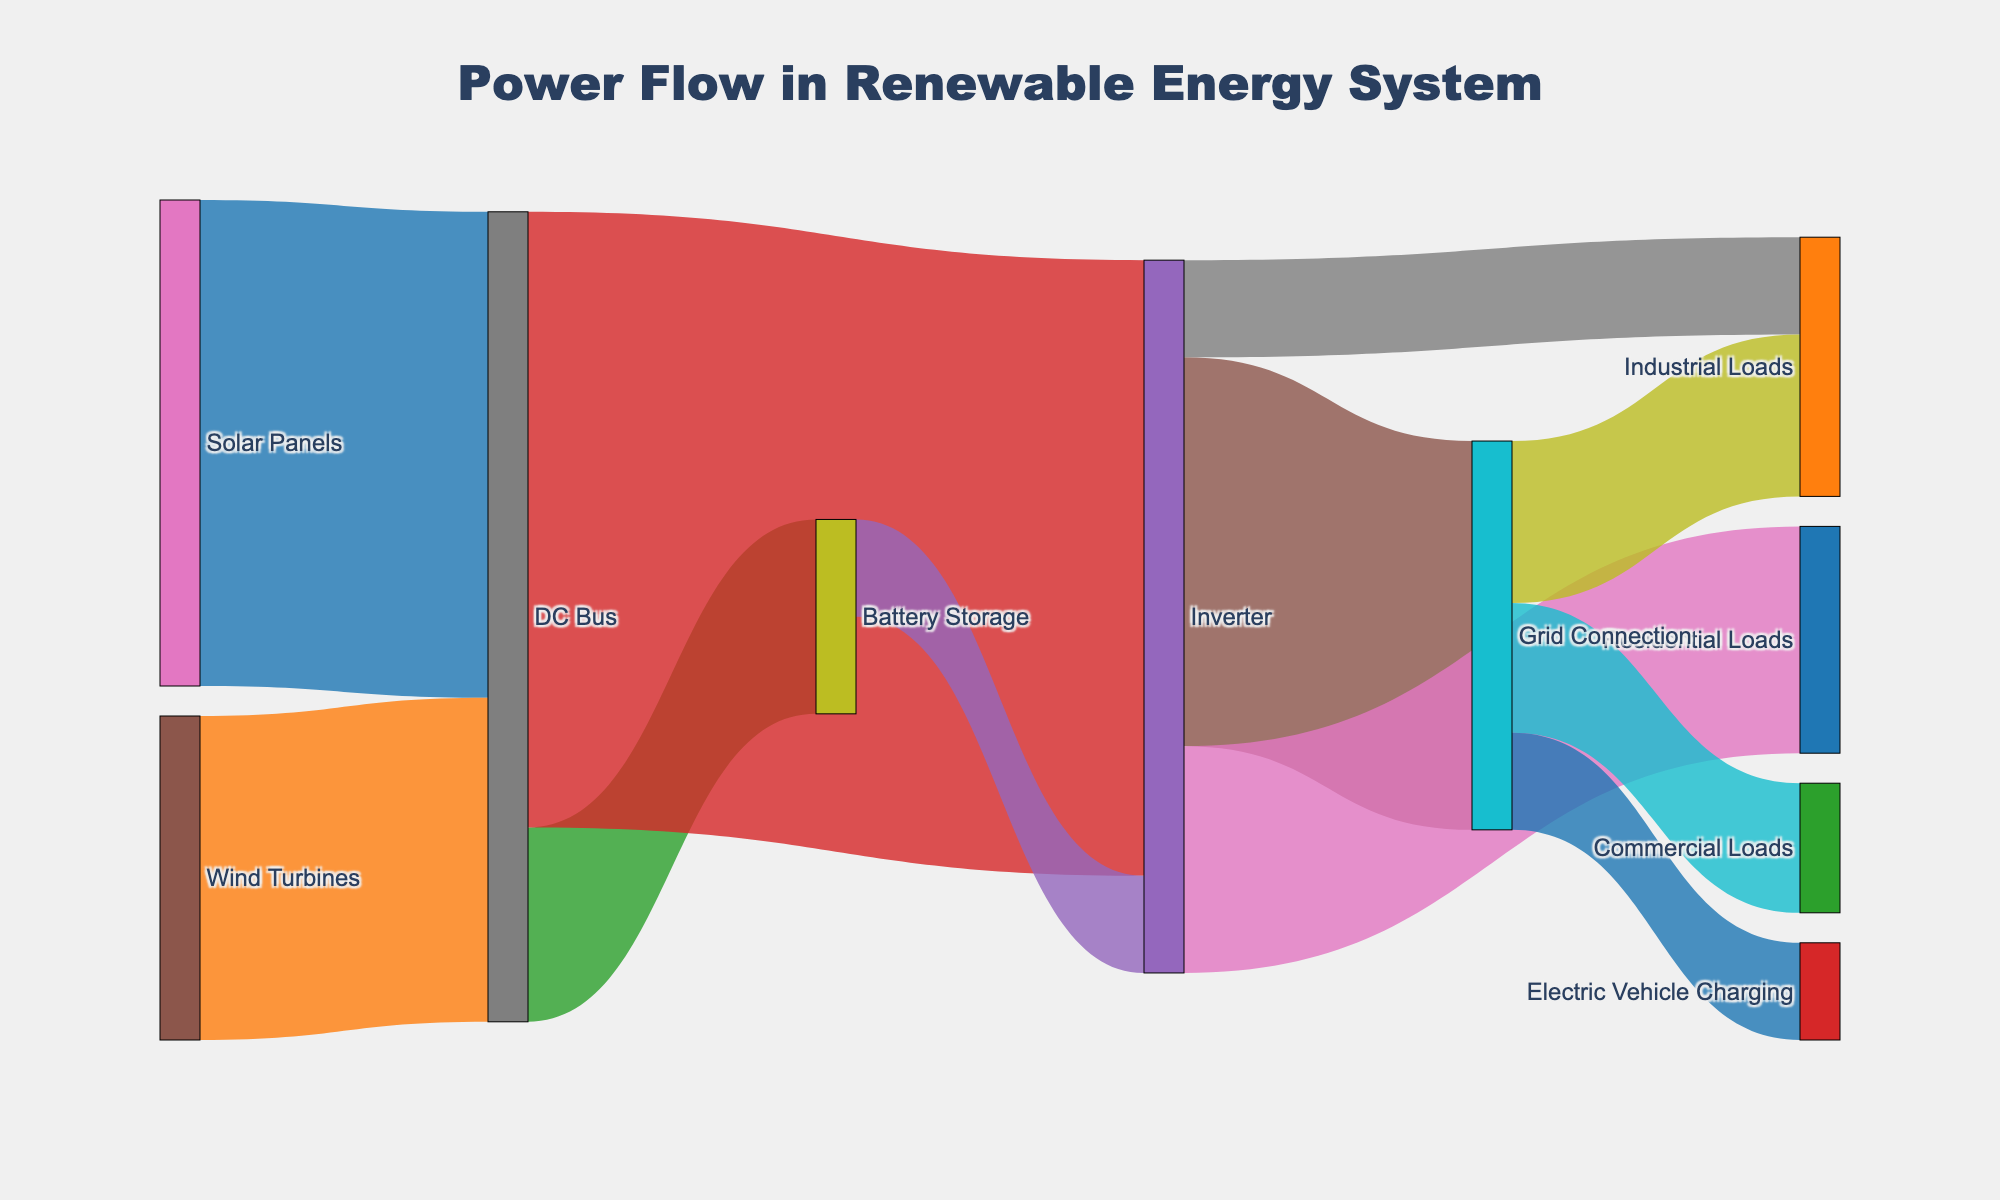What is the title of the Sankey diagram? Look at the top center of the figure where the title is usually placed. It reads "Power Flow in Renewable Energy System".
Answer: Power Flow in Renewable Energy System Which energy source contributes more power to the DC Bus, Solar Panels or Wind Turbines? Check the values from both energy sources to the DC Bus. Solar Panels contribute 150 units, and Wind Turbines contribute 100 units.
Answer: Solar Panels How much total power is delivered to the Inverter? Add the contributions from the DC Bus and Battery Storage to the Inverter: 190 (from DC Bus) + 30 (from Battery Storage) = 220 units.
Answer: 220 units How much power is used by Residential Loads? Look at the link from the Inverter to Residential Loads, which is labeled with the value 70 units.
Answer: 70 units What is the difference in power supplied to Residential Loads and Industrial Loads from the Inverter? Subtract the power delivered to Industrial Loads (30 units) from the power delivered to Residential Loads (70 units): 70 - 30 = 40 units.
Answer: 40 units What is the sum of power flows from Grid Connection to all its targets? Add the values leading from Grid Connection: 50 (Industrial Loads) + 40 (Commercial Loads) + 30 (Electric Vehicle Charging) = 120 units.
Answer: 120 units How does the power flow from Solar Panels compare to the power flow from Battery Storage? Compare the total power flow from each source to their respective targets. The Solar Panels contribute 150 units to the DC Bus, whereas the Battery Storage contributes a total of 60 (to DC Bus) + 30 (to Inverter) = 90 units.
Answer: Solar Panels contribute more Which downstream connections have the longest links in the Sankey diagram? Visually compare the horizontal lengths of all links, those from the Inverter to the Grid Connection, Residential Loads, and Industrial Loads appear to be the longest.
Answer: Inverter to Grid Connection, Residential Loads, Industrial Loads What is the total power generated by the renewable sources (Solar Panels and Wind Turbines)? Add the power contributed by both renewable sources: 150 (Solar Panels) + 100 (Wind Turbines) = 250 units.
Answer: 250 units If the power from the Grid Connection to Industrial Loads is redirected to the DC Bus, what would be the new total power in the DC Bus? First, find the current total in the DC Bus, which is from Solar Panels and Wind Turbines: 150 (Solar Panels) + 100 (Wind Turbines) = 250 units. Add the redirected power from Grid Connection to Industrial Loads: 250 + 50 = 300 units.
Answer: 300 units 